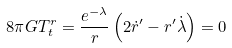<formula> <loc_0><loc_0><loc_500><loc_500>8 \pi G T ^ { r } _ { t } = \frac { e ^ { - \lambda } } { r } \left ( 2 \dot { r } ^ { \prime } - r ^ { \prime } \dot { \lambda } \right ) = 0</formula> 